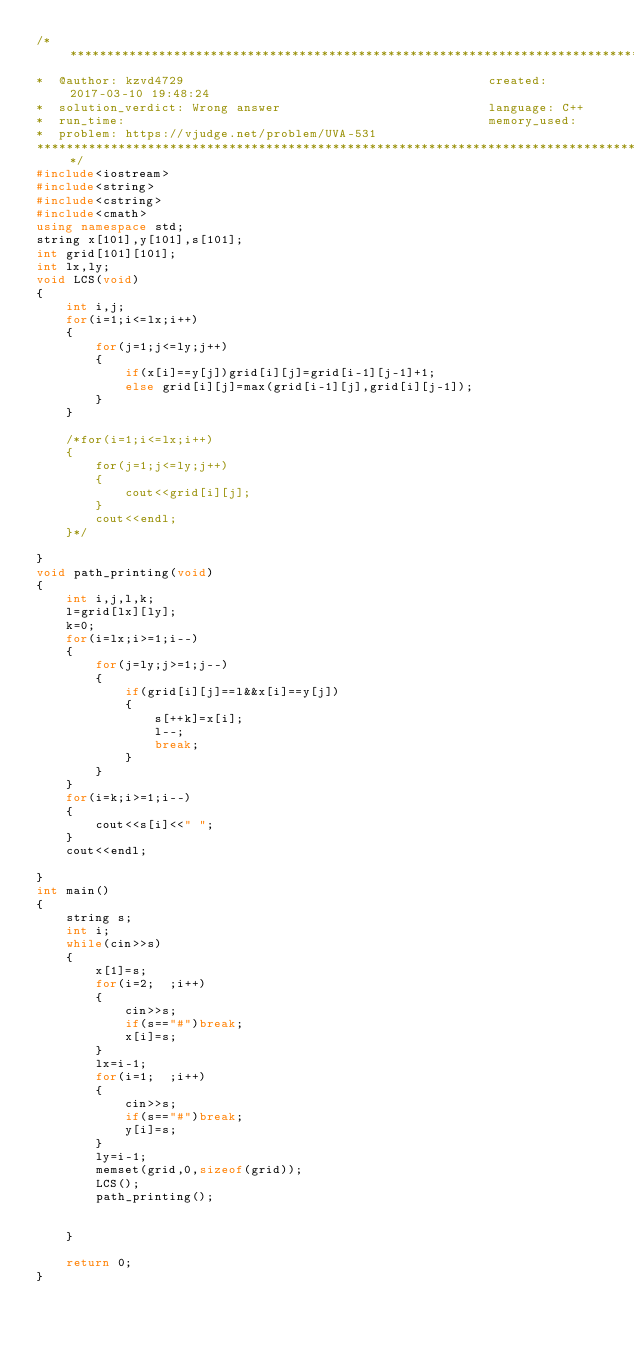Convert code to text. <code><loc_0><loc_0><loc_500><loc_500><_C++_>/****************************************************************************************
*  @author: kzvd4729                                         created: 2017-03-10 19:48:24                      
*  solution_verdict: Wrong answer                            language: C++                                     
*  run_time:                                                 memory_used:                                      
*  problem: https://vjudge.net/problem/UVA-531
****************************************************************************************/
#include<iostream>
#include<string>
#include<cstring>
#include<cmath>
using namespace std;
string x[101],y[101],s[101];
int grid[101][101];
int lx,ly;
void LCS(void)
{
    int i,j;
    for(i=1;i<=lx;i++)
    {
        for(j=1;j<=ly;j++)
        {
            if(x[i]==y[j])grid[i][j]=grid[i-1][j-1]+1;
            else grid[i][j]=max(grid[i-1][j],grid[i][j-1]);
        }
    }

    /*for(i=1;i<=lx;i++)
    {
        for(j=1;j<=ly;j++)
        {
            cout<<grid[i][j];
        }
        cout<<endl;
    }*/

}
void path_printing(void)
{
    int i,j,l,k;
    l=grid[lx][ly];
    k=0;
    for(i=lx;i>=1;i--)
    {
        for(j=ly;j>=1;j--)
        {
            if(grid[i][j]==l&&x[i]==y[j])
            {
                s[++k]=x[i];
                l--;
                break;
            }
        }
    }
    for(i=k;i>=1;i--)
    {
        cout<<s[i]<<" ";
    }
    cout<<endl;

}
int main()
{
    string s;
    int i;
    while(cin>>s)
    {
        x[1]=s;
        for(i=2;  ;i++)
        {
            cin>>s;
            if(s=="#")break;
            x[i]=s;
        }
        lx=i-1;
        for(i=1;  ;i++)
        {
            cin>>s;
            if(s=="#")break;
            y[i]=s;
        }
        ly=i-1;
        memset(grid,0,sizeof(grid));
        LCS();
        path_printing();


    }

    return 0;
}</code> 